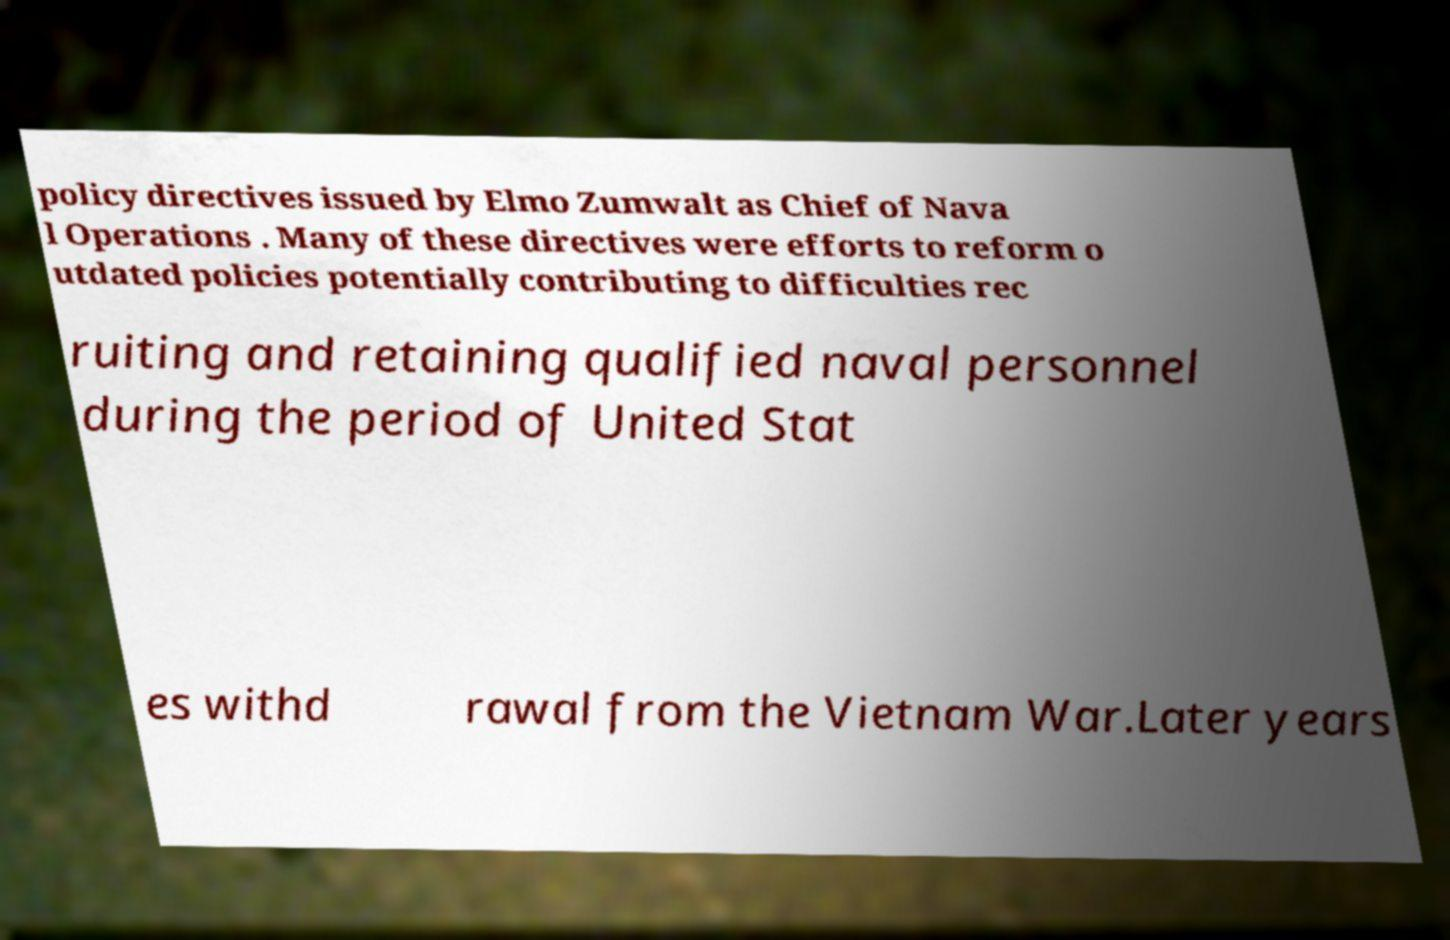Can you accurately transcribe the text from the provided image for me? policy directives issued by Elmo Zumwalt as Chief of Nava l Operations . Many of these directives were efforts to reform o utdated policies potentially contributing to difficulties rec ruiting and retaining qualified naval personnel during the period of United Stat es withd rawal from the Vietnam War.Later years 